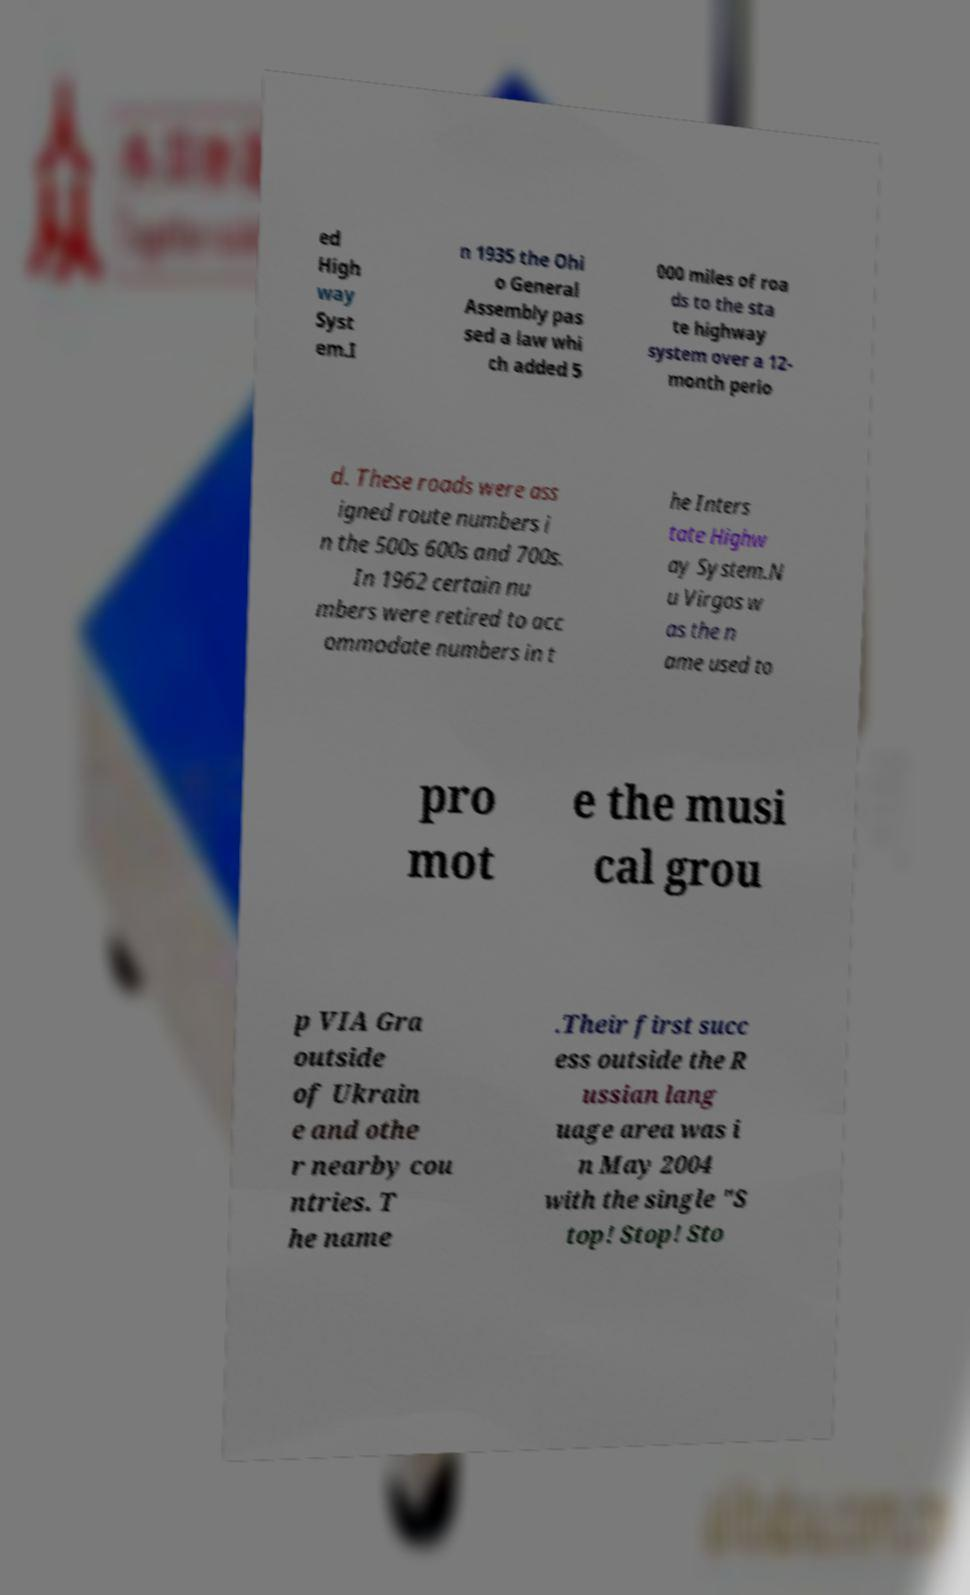For documentation purposes, I need the text within this image transcribed. Could you provide that? ed High way Syst em.I n 1935 the Ohi o General Assembly pas sed a law whi ch added 5 000 miles of roa ds to the sta te highway system over a 12- month perio d. These roads were ass igned route numbers i n the 500s 600s and 700s. In 1962 certain nu mbers were retired to acc ommodate numbers in t he Inters tate Highw ay System.N u Virgos w as the n ame used to pro mot e the musi cal grou p VIA Gra outside of Ukrain e and othe r nearby cou ntries. T he name .Their first succ ess outside the R ussian lang uage area was i n May 2004 with the single "S top! Stop! Sto 